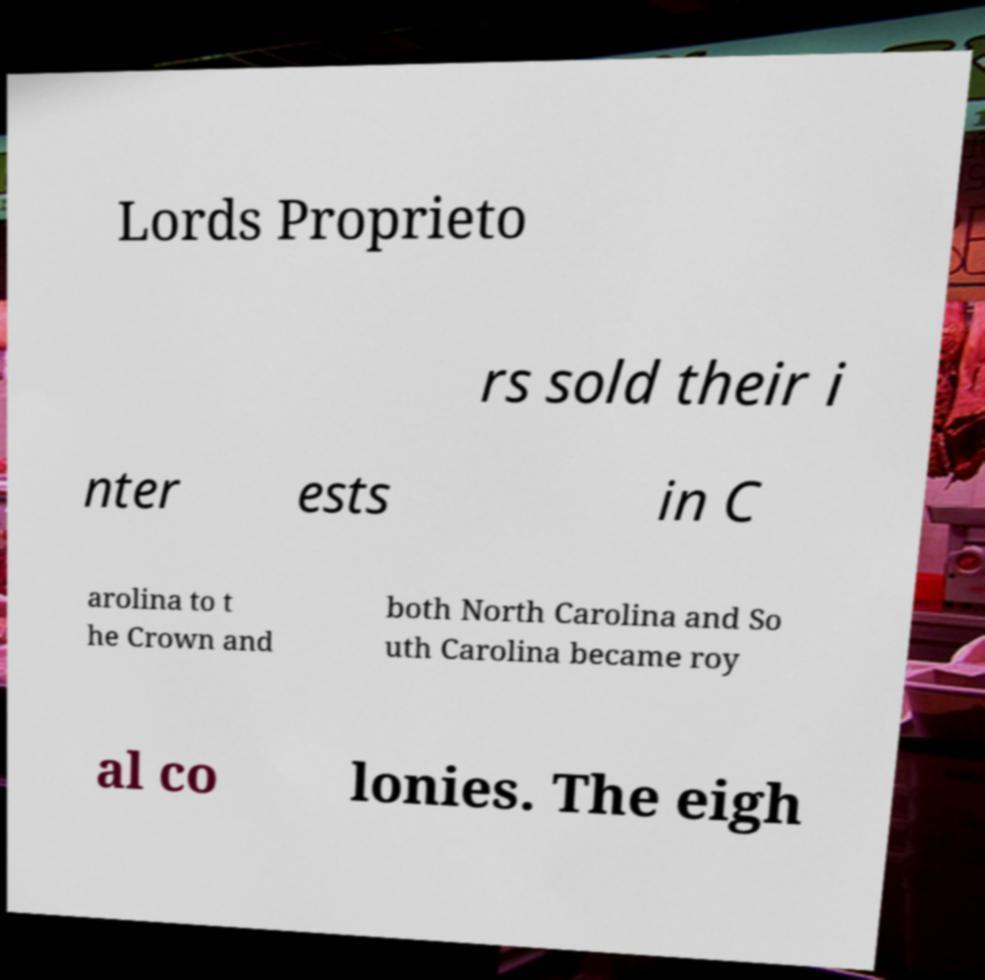Could you extract and type out the text from this image? Lords Proprieto rs sold their i nter ests in C arolina to t he Crown and both North Carolina and So uth Carolina became roy al co lonies. The eigh 